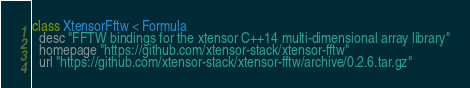Convert code to text. <code><loc_0><loc_0><loc_500><loc_500><_Ruby_>class XtensorFftw < Formula
  desc "FFTW bindings for the xtensor C++14 multi-dimensional array library"
  homepage "https://github.com/xtensor-stack/xtensor-fftw"
  url "https://github.com/xtensor-stack/xtensor-fftw/archive/0.2.6.tar.gz"</code> 